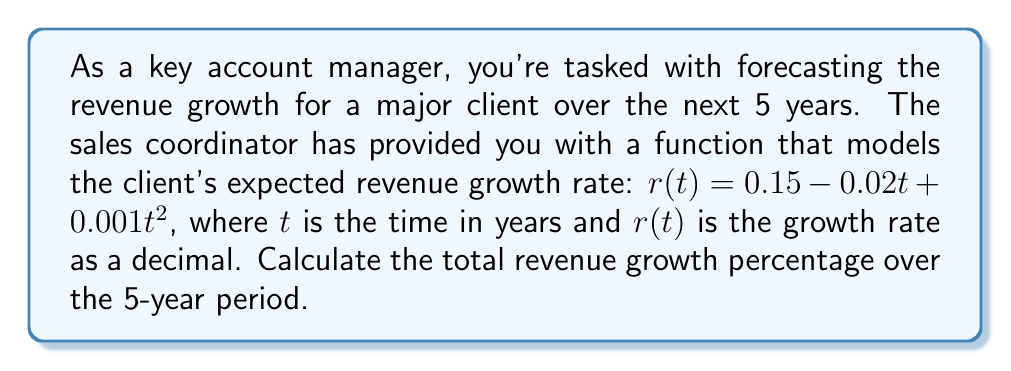Can you solve this math problem? To solve this problem, we need to integrate the growth rate function over the 5-year period. The steps are as follows:

1) The total growth percentage is given by the definite integral of the growth rate function from 0 to 5:

   $$\text{Total Growth} = \int_0^5 r(t) dt$$

2) Substitute the given function:

   $$\int_0^5 (0.15 - 0.02t + 0.001t^2) dt$$

3) Integrate each term:

   $$\left[0.15t - 0.01t^2 + \frac{1}{3000}t^3\right]_0^5$$

4) Evaluate the integral at the bounds:

   $$\left(0.15(5) - 0.01(5^2) + \frac{1}{3000}(5^3)\right) - \left(0.15(0) - 0.01(0^2) + \frac{1}{3000}(0^3)\right)$$

5) Simplify:

   $$\left(0.75 - 0.25 + \frac{125}{3000}\right) - 0$$

6) Calculate:

   $$0.75 - 0.25 + 0.0417 = 0.5417$$

7) Convert to percentage:

   $$0.5417 \times 100\% = 54.17\%$$
Answer: 54.17% 